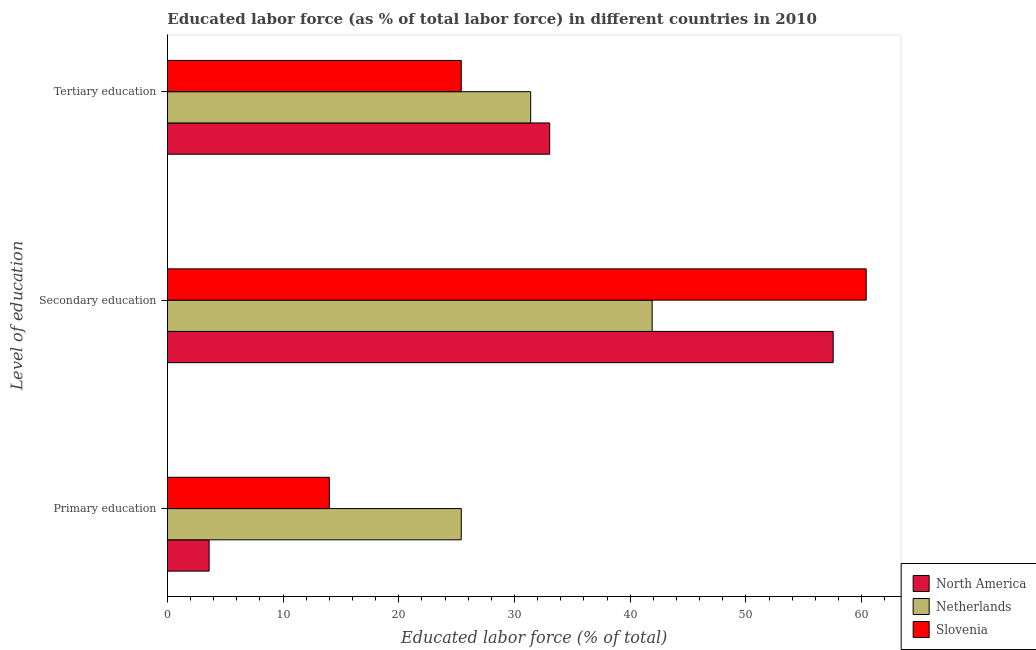How many different coloured bars are there?
Ensure brevity in your answer.  3. Are the number of bars per tick equal to the number of legend labels?
Provide a succinct answer. Yes. Are the number of bars on each tick of the Y-axis equal?
Your answer should be very brief. Yes. How many bars are there on the 1st tick from the top?
Offer a terse response. 3. What is the label of the 2nd group of bars from the top?
Your answer should be very brief. Secondary education. What is the percentage of labor force who received primary education in North America?
Keep it short and to the point. 3.61. Across all countries, what is the maximum percentage of labor force who received tertiary education?
Your response must be concise. 33.04. Across all countries, what is the minimum percentage of labor force who received tertiary education?
Your answer should be compact. 25.4. In which country was the percentage of labor force who received secondary education maximum?
Make the answer very short. Slovenia. What is the total percentage of labor force who received tertiary education in the graph?
Make the answer very short. 89.84. What is the difference between the percentage of labor force who received tertiary education in Netherlands and that in North America?
Provide a succinct answer. -1.64. What is the difference between the percentage of labor force who received secondary education in Slovenia and the percentage of labor force who received tertiary education in North America?
Ensure brevity in your answer.  27.36. What is the average percentage of labor force who received secondary education per country?
Your answer should be compact. 53.28. What is the difference between the percentage of labor force who received secondary education and percentage of labor force who received primary education in Netherlands?
Keep it short and to the point. 16.5. What is the ratio of the percentage of labor force who received secondary education in Slovenia to that in Netherlands?
Ensure brevity in your answer.  1.44. What is the difference between the highest and the second highest percentage of labor force who received secondary education?
Your answer should be compact. 2.85. What is the difference between the highest and the lowest percentage of labor force who received tertiary education?
Make the answer very short. 7.64. In how many countries, is the percentage of labor force who received tertiary education greater than the average percentage of labor force who received tertiary education taken over all countries?
Make the answer very short. 2. Is the sum of the percentage of labor force who received primary education in North America and Slovenia greater than the maximum percentage of labor force who received tertiary education across all countries?
Your answer should be very brief. No. What does the 2nd bar from the top in Primary education represents?
Give a very brief answer. Netherlands. How many bars are there?
Offer a terse response. 9. How many countries are there in the graph?
Offer a very short reply. 3. What is the difference between two consecutive major ticks on the X-axis?
Offer a terse response. 10. Does the graph contain any zero values?
Offer a very short reply. No. How many legend labels are there?
Make the answer very short. 3. What is the title of the graph?
Your answer should be compact. Educated labor force (as % of total labor force) in different countries in 2010. What is the label or title of the X-axis?
Offer a very short reply. Educated labor force (% of total). What is the label or title of the Y-axis?
Your response must be concise. Level of education. What is the Educated labor force (% of total) of North America in Primary education?
Give a very brief answer. 3.61. What is the Educated labor force (% of total) in Netherlands in Primary education?
Keep it short and to the point. 25.4. What is the Educated labor force (% of total) of Slovenia in Primary education?
Ensure brevity in your answer.  14. What is the Educated labor force (% of total) of North America in Secondary education?
Provide a short and direct response. 57.55. What is the Educated labor force (% of total) of Netherlands in Secondary education?
Make the answer very short. 41.9. What is the Educated labor force (% of total) of Slovenia in Secondary education?
Keep it short and to the point. 60.4. What is the Educated labor force (% of total) in North America in Tertiary education?
Provide a succinct answer. 33.04. What is the Educated labor force (% of total) of Netherlands in Tertiary education?
Your response must be concise. 31.4. What is the Educated labor force (% of total) of Slovenia in Tertiary education?
Make the answer very short. 25.4. Across all Level of education, what is the maximum Educated labor force (% of total) in North America?
Keep it short and to the point. 57.55. Across all Level of education, what is the maximum Educated labor force (% of total) in Netherlands?
Provide a short and direct response. 41.9. Across all Level of education, what is the maximum Educated labor force (% of total) of Slovenia?
Give a very brief answer. 60.4. Across all Level of education, what is the minimum Educated labor force (% of total) of North America?
Provide a short and direct response. 3.61. Across all Level of education, what is the minimum Educated labor force (% of total) of Netherlands?
Your answer should be compact. 25.4. Across all Level of education, what is the minimum Educated labor force (% of total) of Slovenia?
Provide a short and direct response. 14. What is the total Educated labor force (% of total) of North America in the graph?
Your answer should be very brief. 94.2. What is the total Educated labor force (% of total) in Netherlands in the graph?
Offer a terse response. 98.7. What is the total Educated labor force (% of total) of Slovenia in the graph?
Your answer should be very brief. 99.8. What is the difference between the Educated labor force (% of total) in North America in Primary education and that in Secondary education?
Your answer should be compact. -53.94. What is the difference between the Educated labor force (% of total) of Netherlands in Primary education and that in Secondary education?
Provide a succinct answer. -16.5. What is the difference between the Educated labor force (% of total) in Slovenia in Primary education and that in Secondary education?
Provide a succinct answer. -46.4. What is the difference between the Educated labor force (% of total) in North America in Primary education and that in Tertiary education?
Offer a terse response. -29.44. What is the difference between the Educated labor force (% of total) in Netherlands in Primary education and that in Tertiary education?
Your answer should be very brief. -6. What is the difference between the Educated labor force (% of total) in North America in Secondary education and that in Tertiary education?
Provide a succinct answer. 24.5. What is the difference between the Educated labor force (% of total) of Netherlands in Secondary education and that in Tertiary education?
Offer a very short reply. 10.5. What is the difference between the Educated labor force (% of total) in North America in Primary education and the Educated labor force (% of total) in Netherlands in Secondary education?
Keep it short and to the point. -38.29. What is the difference between the Educated labor force (% of total) of North America in Primary education and the Educated labor force (% of total) of Slovenia in Secondary education?
Your response must be concise. -56.79. What is the difference between the Educated labor force (% of total) in Netherlands in Primary education and the Educated labor force (% of total) in Slovenia in Secondary education?
Provide a succinct answer. -35. What is the difference between the Educated labor force (% of total) in North America in Primary education and the Educated labor force (% of total) in Netherlands in Tertiary education?
Provide a succinct answer. -27.79. What is the difference between the Educated labor force (% of total) in North America in Primary education and the Educated labor force (% of total) in Slovenia in Tertiary education?
Provide a succinct answer. -21.79. What is the difference between the Educated labor force (% of total) in Netherlands in Primary education and the Educated labor force (% of total) in Slovenia in Tertiary education?
Provide a succinct answer. 0. What is the difference between the Educated labor force (% of total) of North America in Secondary education and the Educated labor force (% of total) of Netherlands in Tertiary education?
Ensure brevity in your answer.  26.15. What is the difference between the Educated labor force (% of total) in North America in Secondary education and the Educated labor force (% of total) in Slovenia in Tertiary education?
Make the answer very short. 32.15. What is the difference between the Educated labor force (% of total) in Netherlands in Secondary education and the Educated labor force (% of total) in Slovenia in Tertiary education?
Keep it short and to the point. 16.5. What is the average Educated labor force (% of total) of North America per Level of education?
Your response must be concise. 31.4. What is the average Educated labor force (% of total) in Netherlands per Level of education?
Make the answer very short. 32.9. What is the average Educated labor force (% of total) in Slovenia per Level of education?
Give a very brief answer. 33.27. What is the difference between the Educated labor force (% of total) of North America and Educated labor force (% of total) of Netherlands in Primary education?
Ensure brevity in your answer.  -21.79. What is the difference between the Educated labor force (% of total) of North America and Educated labor force (% of total) of Slovenia in Primary education?
Provide a succinct answer. -10.39. What is the difference between the Educated labor force (% of total) in Netherlands and Educated labor force (% of total) in Slovenia in Primary education?
Your response must be concise. 11.4. What is the difference between the Educated labor force (% of total) of North America and Educated labor force (% of total) of Netherlands in Secondary education?
Your response must be concise. 15.65. What is the difference between the Educated labor force (% of total) in North America and Educated labor force (% of total) in Slovenia in Secondary education?
Give a very brief answer. -2.85. What is the difference between the Educated labor force (% of total) in Netherlands and Educated labor force (% of total) in Slovenia in Secondary education?
Your answer should be compact. -18.5. What is the difference between the Educated labor force (% of total) in North America and Educated labor force (% of total) in Netherlands in Tertiary education?
Ensure brevity in your answer.  1.64. What is the difference between the Educated labor force (% of total) of North America and Educated labor force (% of total) of Slovenia in Tertiary education?
Keep it short and to the point. 7.64. What is the ratio of the Educated labor force (% of total) in North America in Primary education to that in Secondary education?
Your answer should be very brief. 0.06. What is the ratio of the Educated labor force (% of total) of Netherlands in Primary education to that in Secondary education?
Offer a terse response. 0.61. What is the ratio of the Educated labor force (% of total) in Slovenia in Primary education to that in Secondary education?
Keep it short and to the point. 0.23. What is the ratio of the Educated labor force (% of total) in North America in Primary education to that in Tertiary education?
Offer a terse response. 0.11. What is the ratio of the Educated labor force (% of total) in Netherlands in Primary education to that in Tertiary education?
Offer a very short reply. 0.81. What is the ratio of the Educated labor force (% of total) of Slovenia in Primary education to that in Tertiary education?
Make the answer very short. 0.55. What is the ratio of the Educated labor force (% of total) of North America in Secondary education to that in Tertiary education?
Offer a terse response. 1.74. What is the ratio of the Educated labor force (% of total) in Netherlands in Secondary education to that in Tertiary education?
Ensure brevity in your answer.  1.33. What is the ratio of the Educated labor force (% of total) in Slovenia in Secondary education to that in Tertiary education?
Make the answer very short. 2.38. What is the difference between the highest and the second highest Educated labor force (% of total) in North America?
Your response must be concise. 24.5. What is the difference between the highest and the second highest Educated labor force (% of total) in Slovenia?
Offer a very short reply. 35. What is the difference between the highest and the lowest Educated labor force (% of total) in North America?
Ensure brevity in your answer.  53.94. What is the difference between the highest and the lowest Educated labor force (% of total) of Slovenia?
Ensure brevity in your answer.  46.4. 